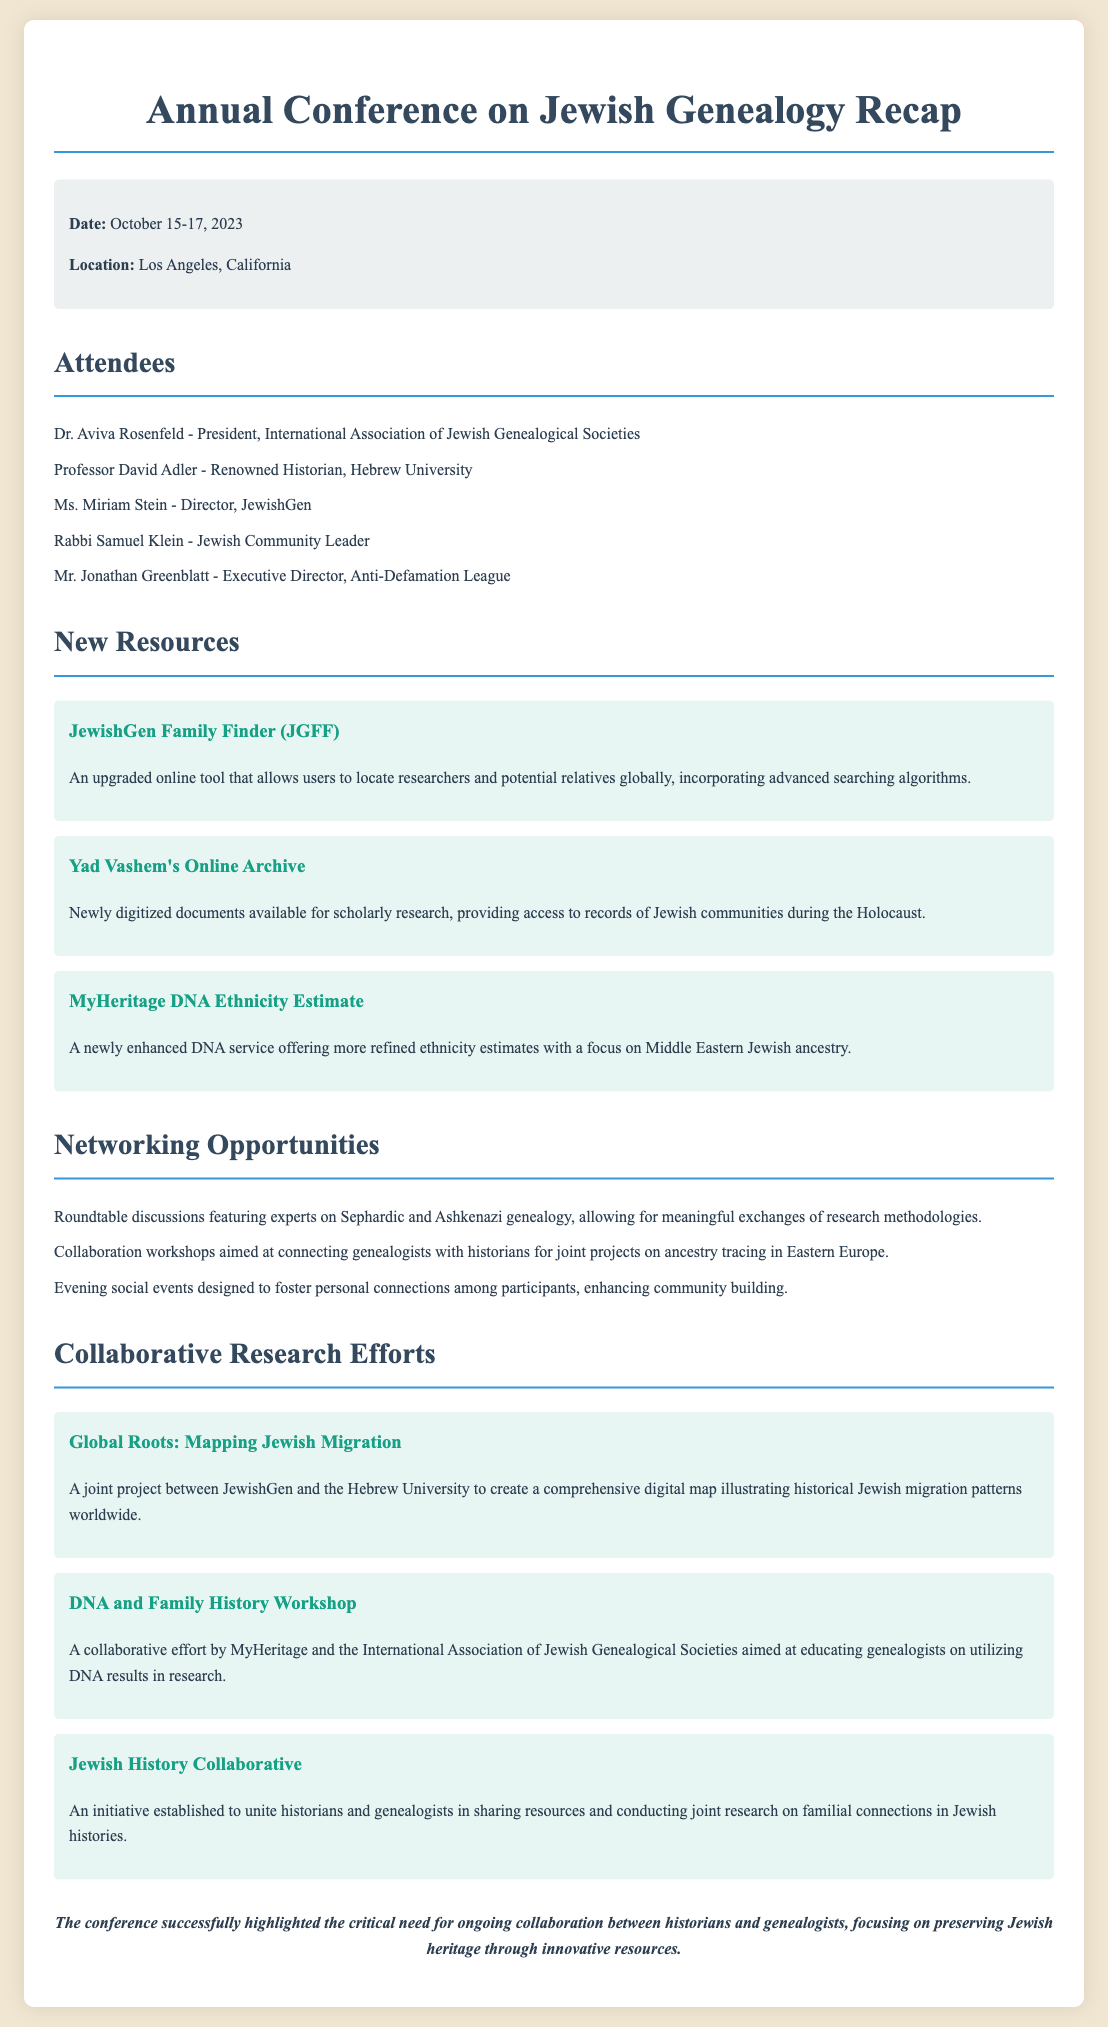What are the dates of the conference? The dates of the conference are provided explicitly in the document, which states October 15-17, 2023.
Answer: October 15-17, 2023 Where was the conference held? The location of the conference is mentioned in the document as Los Angeles, California.
Answer: Los Angeles, California Who is Dr. Aviva Rosenfeld? Dr. Aviva Rosenfeld is identified in the document as the President of the International Association of Jewish Genealogical Societies.
Answer: President, International Association of Jewish Genealogical Societies What is one new resource announced at the conference? The document lists several new resources, one of which is the JewishGen Family Finder (JGFF).
Answer: JewishGen Family Finder (JGFF) What is the focus of the newly enhanced MyHeritage DNA service? The document specifies that the MyHeritage DNA service focuses on more refined ethnicity estimates and Middle Eastern Jewish ancestry.
Answer: Middle Eastern Jewish ancestry What is the purpose of the "Global Roots" project? The purpose of the Global Roots project, as stated in the document, is to create a comprehensive digital map illustrating historical Jewish migration patterns worldwide.
Answer: Mapping historical Jewish migration patterns worldwide What type of event was organized to foster personal connections? The document mentions evening social events that are designed to foster personal connections among participants.
Answer: Evening social events How many collaborative research efforts were mentioned? The document lists three collaborative research efforts as part of the conference highlights.
Answer: Three 